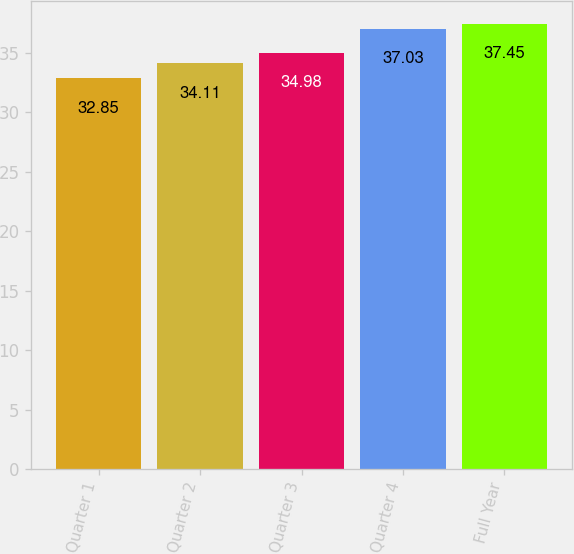Convert chart. <chart><loc_0><loc_0><loc_500><loc_500><bar_chart><fcel>Quarter 1<fcel>Quarter 2<fcel>Quarter 3<fcel>Quarter 4<fcel>Full Year<nl><fcel>32.85<fcel>34.11<fcel>34.98<fcel>37.03<fcel>37.45<nl></chart> 